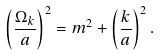Convert formula to latex. <formula><loc_0><loc_0><loc_500><loc_500>\left ( \frac { \Omega _ { k } } { a } \right ) ^ { 2 } = m ^ { 2 } + \left ( \frac { k } { a } \right ) ^ { 2 } .</formula> 